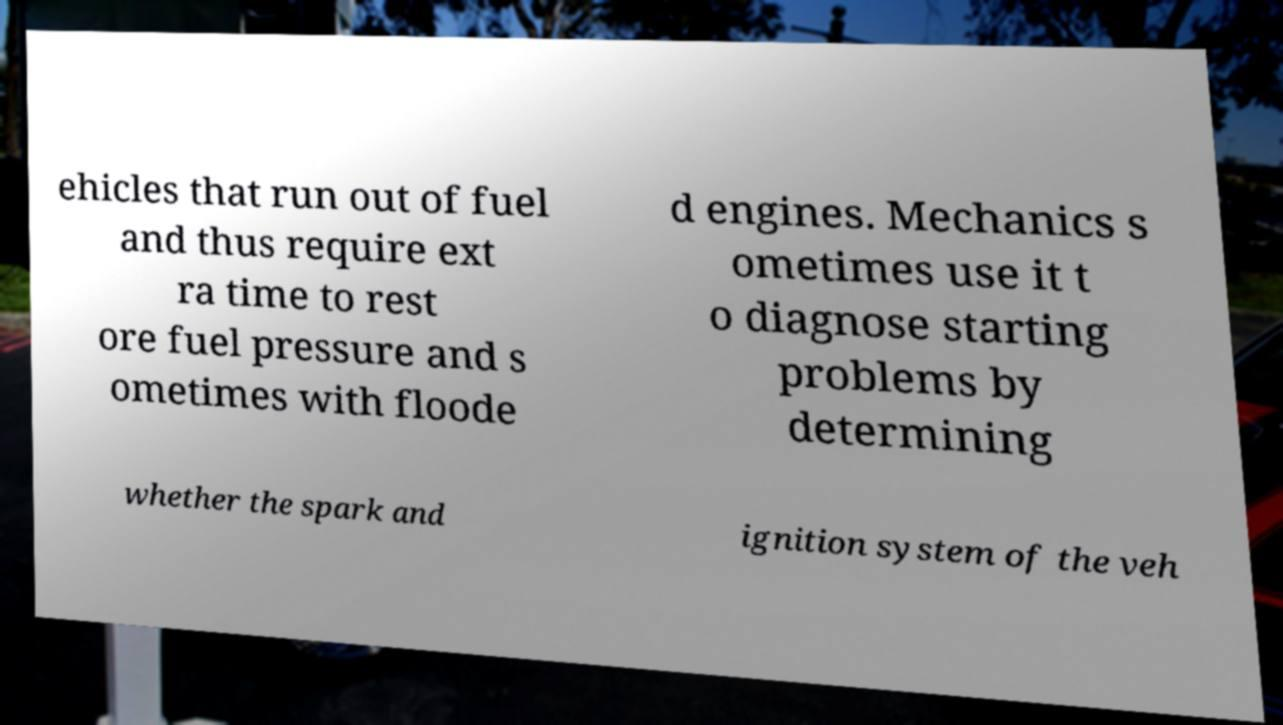For documentation purposes, I need the text within this image transcribed. Could you provide that? ehicles that run out of fuel and thus require ext ra time to rest ore fuel pressure and s ometimes with floode d engines. Mechanics s ometimes use it t o diagnose starting problems by determining whether the spark and ignition system of the veh 